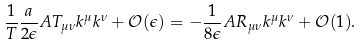Convert formula to latex. <formula><loc_0><loc_0><loc_500><loc_500>\frac { 1 } { T } \frac { a } { 2 \epsilon } A T _ { \mu \nu } k ^ { \mu } k ^ { \nu } + \mathcal { O } ( \epsilon ) = - \frac { 1 } { 8 \epsilon } A R _ { \mu \nu } k ^ { \mu } k ^ { \nu } + \mathcal { O } ( 1 ) .</formula> 